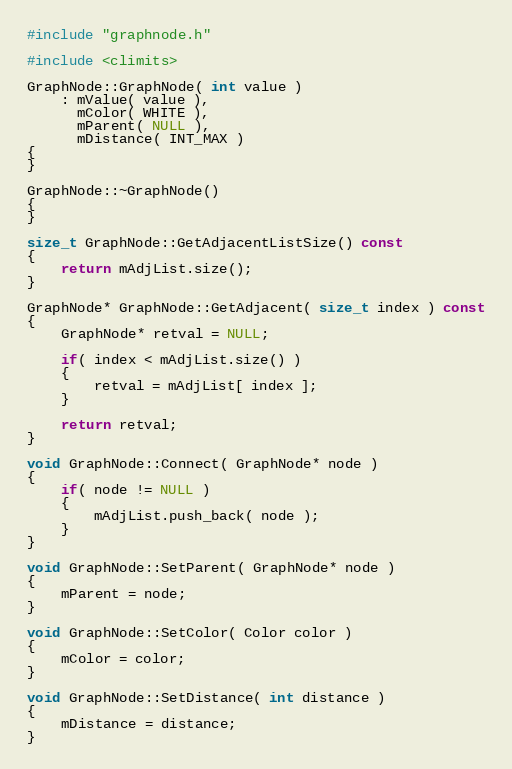<code> <loc_0><loc_0><loc_500><loc_500><_C++_>#include "graphnode.h"

#include <climits>

GraphNode::GraphNode( int value )
    : mValue( value ),
      mColor( WHITE ),
      mParent( NULL ),
      mDistance( INT_MAX )
{
}

GraphNode::~GraphNode()
{
}

size_t GraphNode::GetAdjacentListSize() const
{
    return mAdjList.size();
}

GraphNode* GraphNode::GetAdjacent( size_t index ) const
{
    GraphNode* retval = NULL;

    if( index < mAdjList.size() )
    {
        retval = mAdjList[ index ];
    }

    return retval;
}

void GraphNode::Connect( GraphNode* node )
{
    if( node != NULL )
    {
        mAdjList.push_back( node );
    }
}

void GraphNode::SetParent( GraphNode* node )
{
    mParent = node;
}

void GraphNode::SetColor( Color color )
{
    mColor = color;
}

void GraphNode::SetDistance( int distance )
{
    mDistance = distance;
}
</code> 